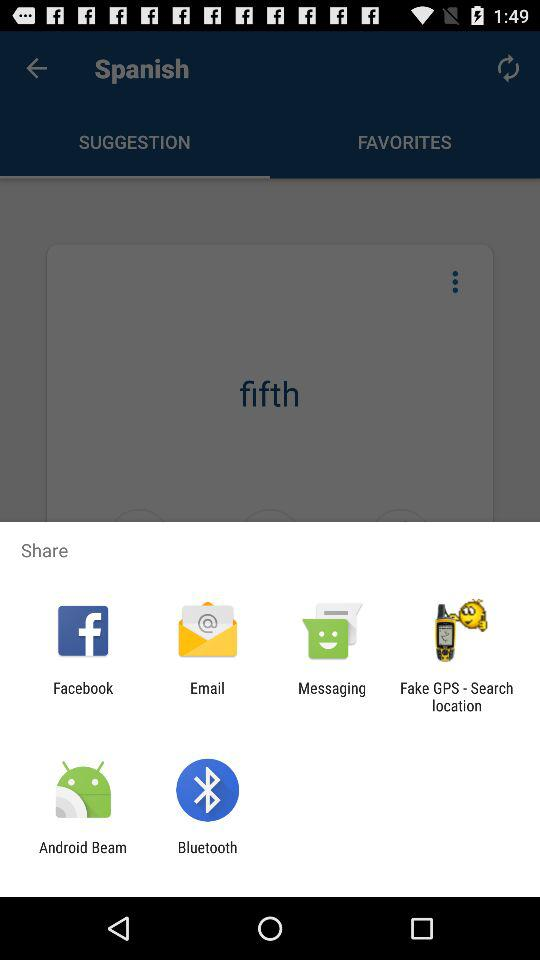By which app can we share? You can share with "Facebook", "Email", "Messaging", "Fake GPS - Search location", "Android Beam" and "Bluetooth". 